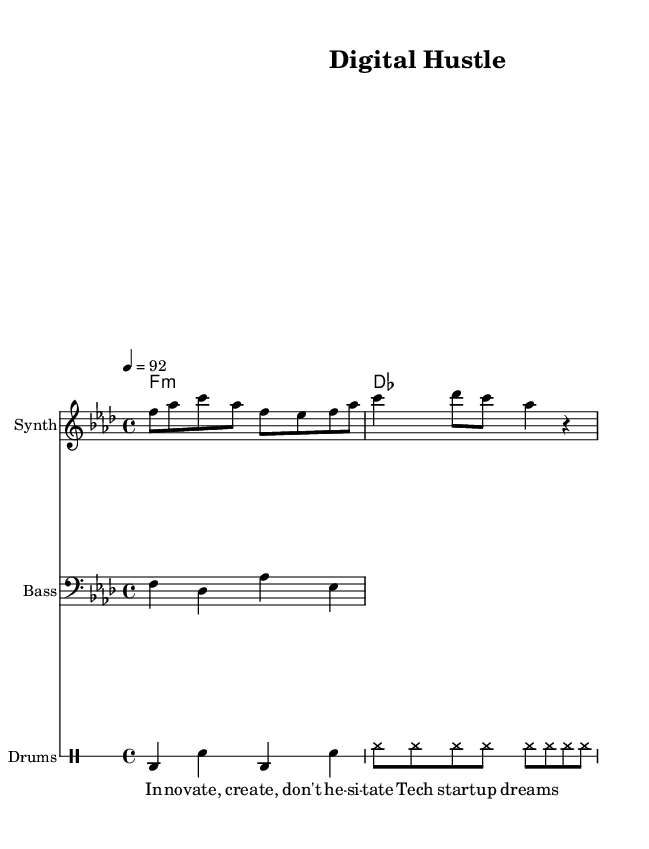What is the key signature of this music? The key signature is indicated by the notes in the melody section. In this case, it is F minor, which is confirmed by the presence of four flats in the key signature.
Answer: F minor What is the time signature of this music? The time signature is displayed at the beginning of the score. It shows the division of beats, which in this case is 4/4, meaning there are four beats per measure.
Answer: 4/4 What is the tempo marking for this piece? The tempo marking can be found in the score, where it indicates the speed of the piece. Here, it states "4 = 92," meaning there are 92 quarter-note beats per minute.
Answer: 92 What type of instruments are used in this piece? The score lists instruments under each staff. There are three instrumental parts: Synth for the melody, Bass for the bass line, and Drums for the rhythm accompaniment.
Answer: Synth, Bass, Drums How many measures are there in the melody? To count the measures in the melody, we look at the melody line within the score. There are two distinct measures present within the provided melody.
Answer: 2 What is the main theme of the lyrics? Upon examining the lyrics beneath the melody in the score, the main theme revolves around innovation and tech startup aspirations, specifically focusing on the concepts of creating and not hesitating.
Answer: Innovation, tech startups 